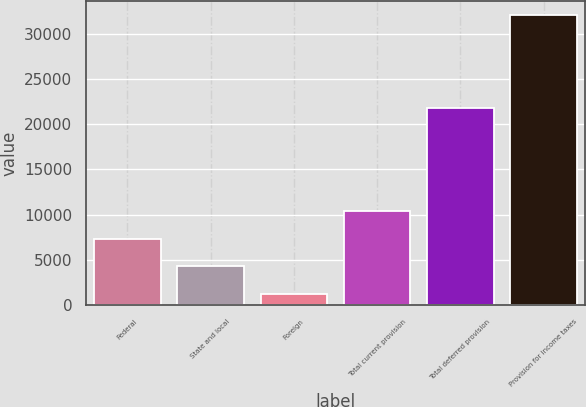<chart> <loc_0><loc_0><loc_500><loc_500><bar_chart><fcel>Federal<fcel>State and local<fcel>Foreign<fcel>Total current provision<fcel>Total deferred provision<fcel>Provision for income taxes<nl><fcel>7355.8<fcel>4274.9<fcel>1194<fcel>10436.7<fcel>21773<fcel>32003<nl></chart> 